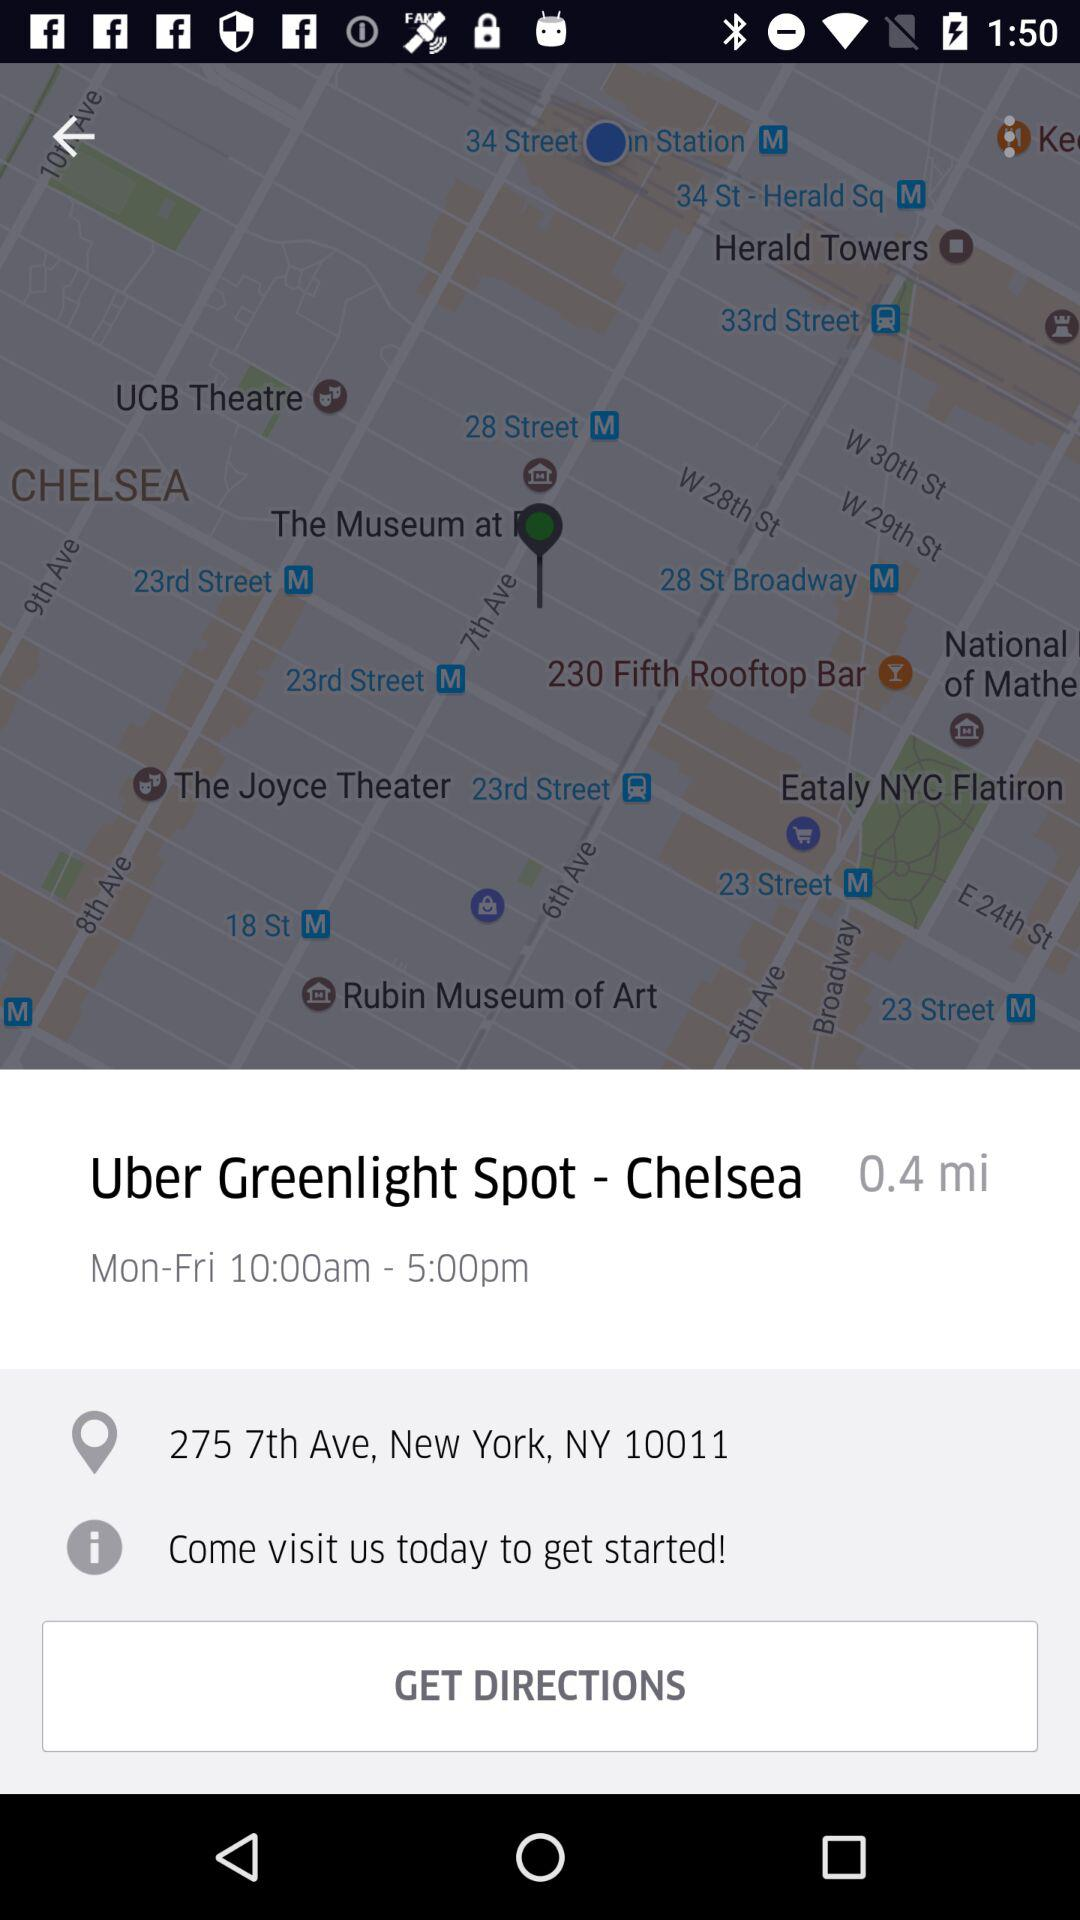What is the distance between this location and the Greenlight Spot?
Answer the question using a single word or phrase. 0.4 mi 